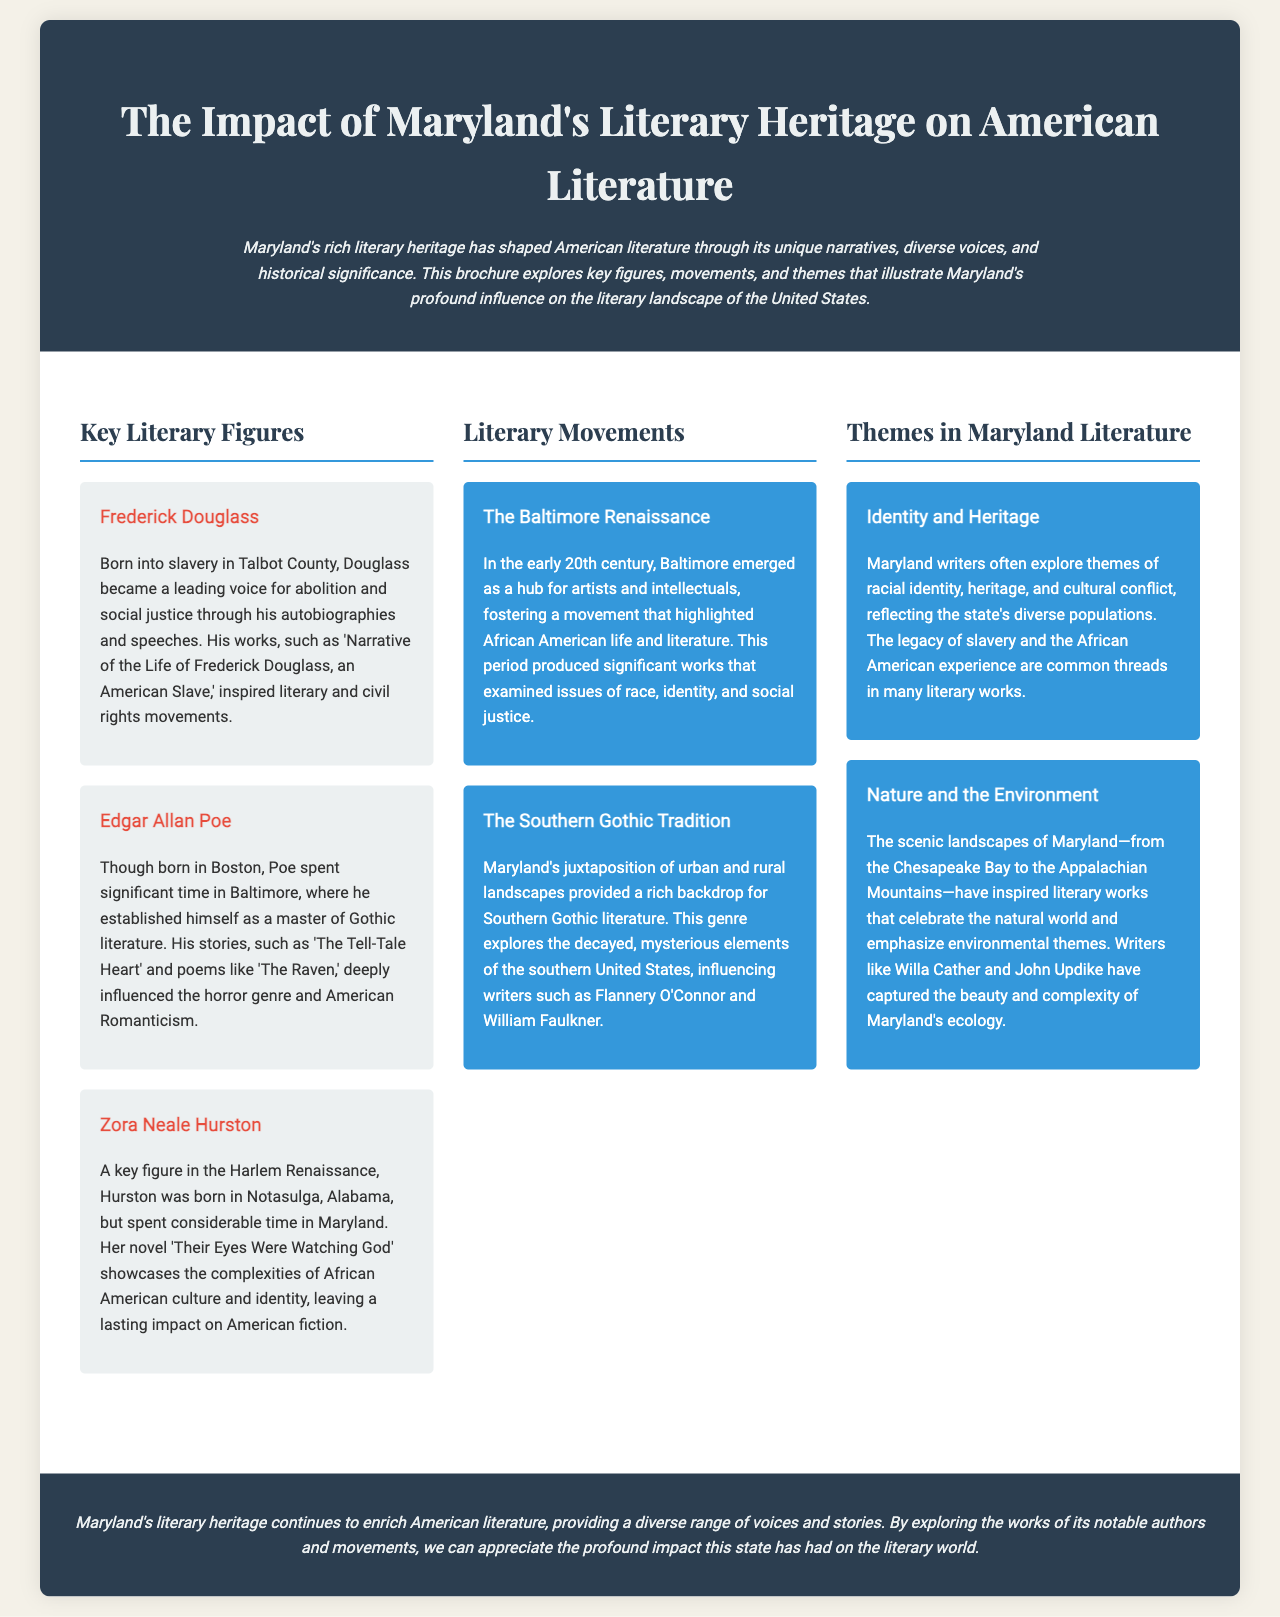What is the title of the brochure? The title of the brochure is prominently displayed in the header section.
Answer: The Impact of Maryland's Literary Heritage on American Literature Who is a key figure associated with abolition? The brochure mentions Frederick Douglass as a leader in abolition and social justice.
Answer: Frederick Douglass Which literary movement emerged in early 20th century Baltimore? The brochure describes a specific movement that highlights African American life and literature.
Answer: The Baltimore Renaissance What theme do Maryland writers often explore related to racial issues? The document states that racial identity and heritage are common exploration themes in Maryland literature.
Answer: Identity and Heritage Name a notable author influenced by Maryland's landscapes. The brochure mentions that several writers capture Maryland's natural beauty, including Willa Cather.
Answer: Willa Cather What genre examines mysterious elements of the southern United States? The document specifically references a tradition that explores such themes related to the environment and history.
Answer: Southern Gothic Tradition What natural feature of Maryland is mentioned as an inspiration for writers? The brochure lists a specific geographic area that has influenced literary works.
Answer: Chesapeake Bay Which poem by Edgar Allan Poe is mentioned? The text includes a specific title that exemplifies Poe's influence on American literature.
Answer: The Raven 